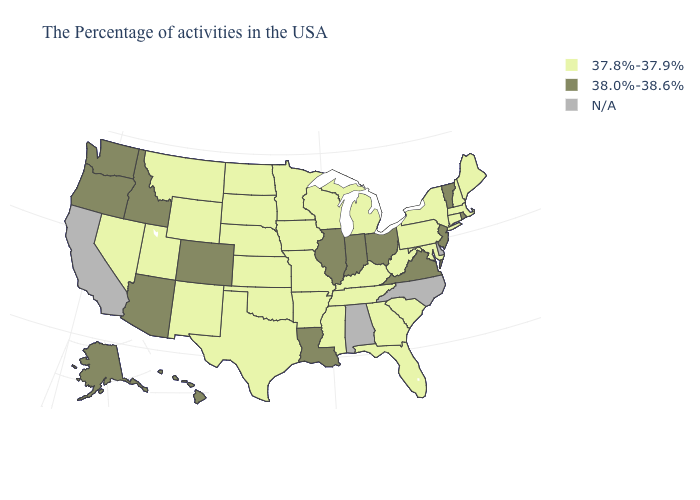Name the states that have a value in the range N/A?
Answer briefly. Delaware, North Carolina, Alabama, California. What is the value of Ohio?
Short answer required. 38.0%-38.6%. What is the value of Mississippi?
Give a very brief answer. 37.8%-37.9%. Name the states that have a value in the range 37.8%-37.9%?
Concise answer only. Maine, Massachusetts, New Hampshire, Connecticut, New York, Maryland, Pennsylvania, South Carolina, West Virginia, Florida, Georgia, Michigan, Kentucky, Tennessee, Wisconsin, Mississippi, Missouri, Arkansas, Minnesota, Iowa, Kansas, Nebraska, Oklahoma, Texas, South Dakota, North Dakota, Wyoming, New Mexico, Utah, Montana, Nevada. Which states have the lowest value in the USA?
Answer briefly. Maine, Massachusetts, New Hampshire, Connecticut, New York, Maryland, Pennsylvania, South Carolina, West Virginia, Florida, Georgia, Michigan, Kentucky, Tennessee, Wisconsin, Mississippi, Missouri, Arkansas, Minnesota, Iowa, Kansas, Nebraska, Oklahoma, Texas, South Dakota, North Dakota, Wyoming, New Mexico, Utah, Montana, Nevada. Name the states that have a value in the range 37.8%-37.9%?
Keep it brief. Maine, Massachusetts, New Hampshire, Connecticut, New York, Maryland, Pennsylvania, South Carolina, West Virginia, Florida, Georgia, Michigan, Kentucky, Tennessee, Wisconsin, Mississippi, Missouri, Arkansas, Minnesota, Iowa, Kansas, Nebraska, Oklahoma, Texas, South Dakota, North Dakota, Wyoming, New Mexico, Utah, Montana, Nevada. Name the states that have a value in the range N/A?
Give a very brief answer. Delaware, North Carolina, Alabama, California. What is the highest value in the USA?
Quick response, please. 38.0%-38.6%. Among the states that border Kentucky , which have the highest value?
Quick response, please. Virginia, Ohio, Indiana, Illinois. Which states have the highest value in the USA?
Quick response, please. Rhode Island, Vermont, New Jersey, Virginia, Ohio, Indiana, Illinois, Louisiana, Colorado, Arizona, Idaho, Washington, Oregon, Alaska, Hawaii. Among the states that border West Virginia , which have the highest value?
Concise answer only. Virginia, Ohio. Name the states that have a value in the range 38.0%-38.6%?
Be succinct. Rhode Island, Vermont, New Jersey, Virginia, Ohio, Indiana, Illinois, Louisiana, Colorado, Arizona, Idaho, Washington, Oregon, Alaska, Hawaii. What is the value of Georgia?
Quick response, please. 37.8%-37.9%. What is the lowest value in states that border Kansas?
Concise answer only. 37.8%-37.9%. Is the legend a continuous bar?
Keep it brief. No. 